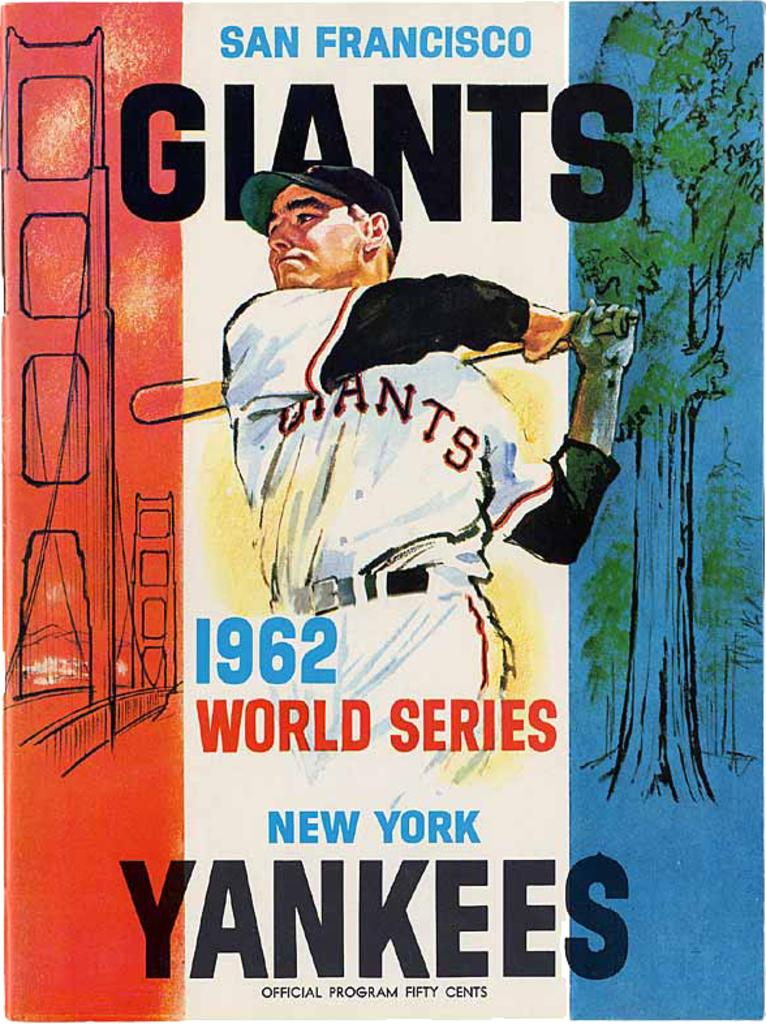<image>
Describe the image concisely. A program for a Giants and Yankees game from the 1962 world series. 